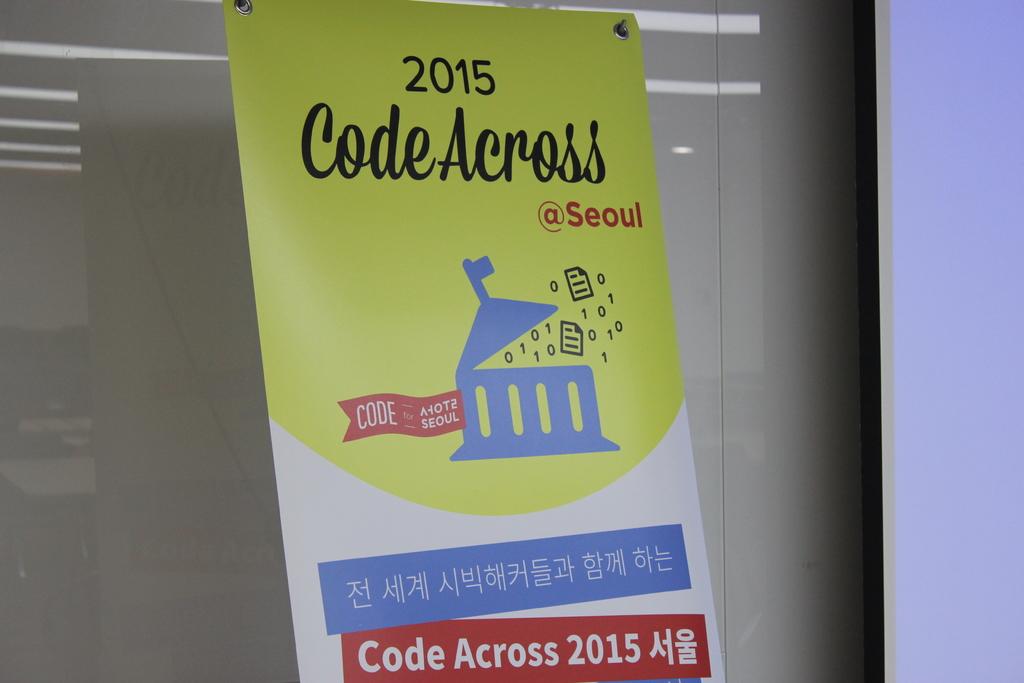What year is on the sign?
Provide a short and direct response. 2015. What is the code on the sign?
Keep it short and to the point. Code across 2015. 